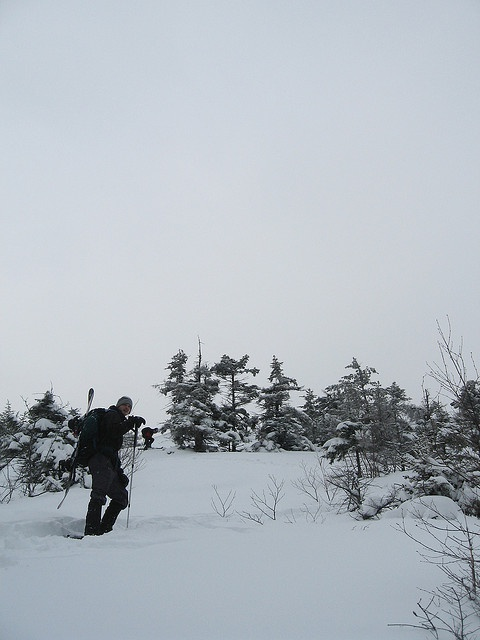Describe the objects in this image and their specific colors. I can see people in lightgray, black, gray, and darkgray tones in this image. 